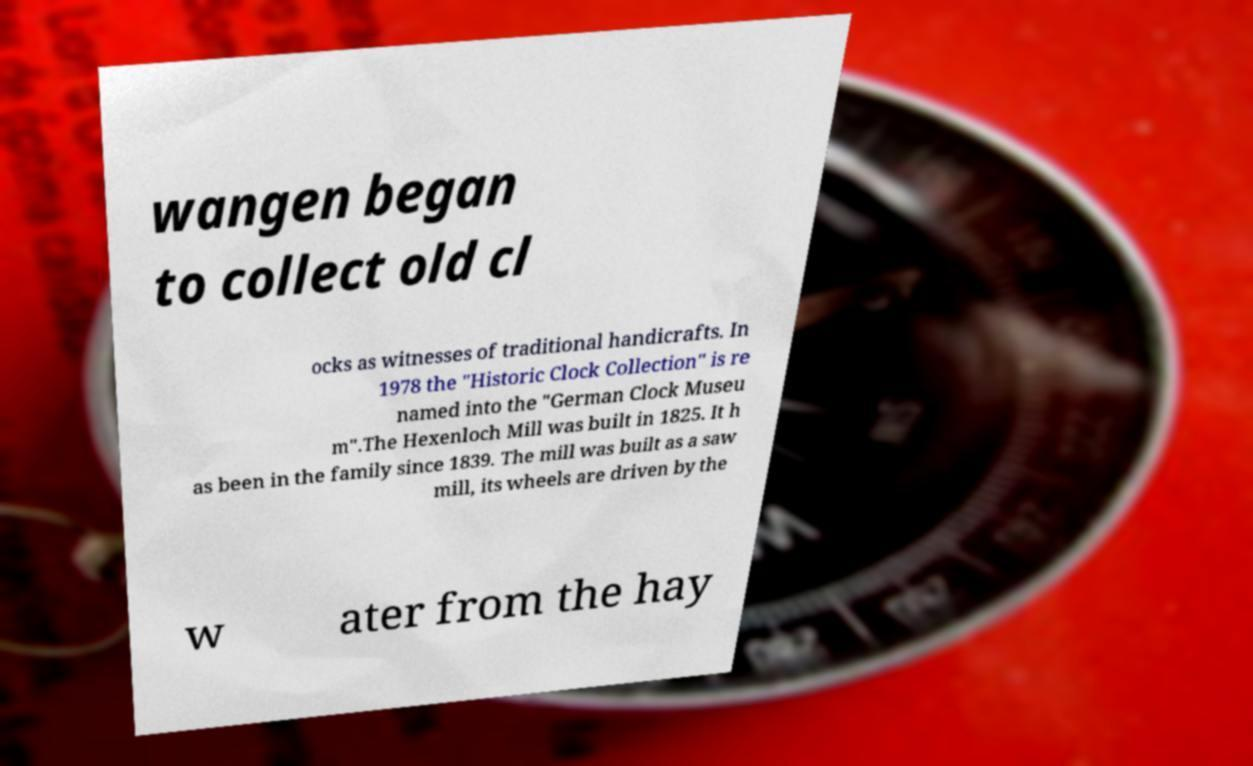Can you accurately transcribe the text from the provided image for me? wangen began to collect old cl ocks as witnesses of traditional handicrafts. In 1978 the "Historic Clock Collection" is re named into the "German Clock Museu m".The Hexenloch Mill was built in 1825. It h as been in the family since 1839. The mill was built as a saw mill, its wheels are driven by the w ater from the hay 